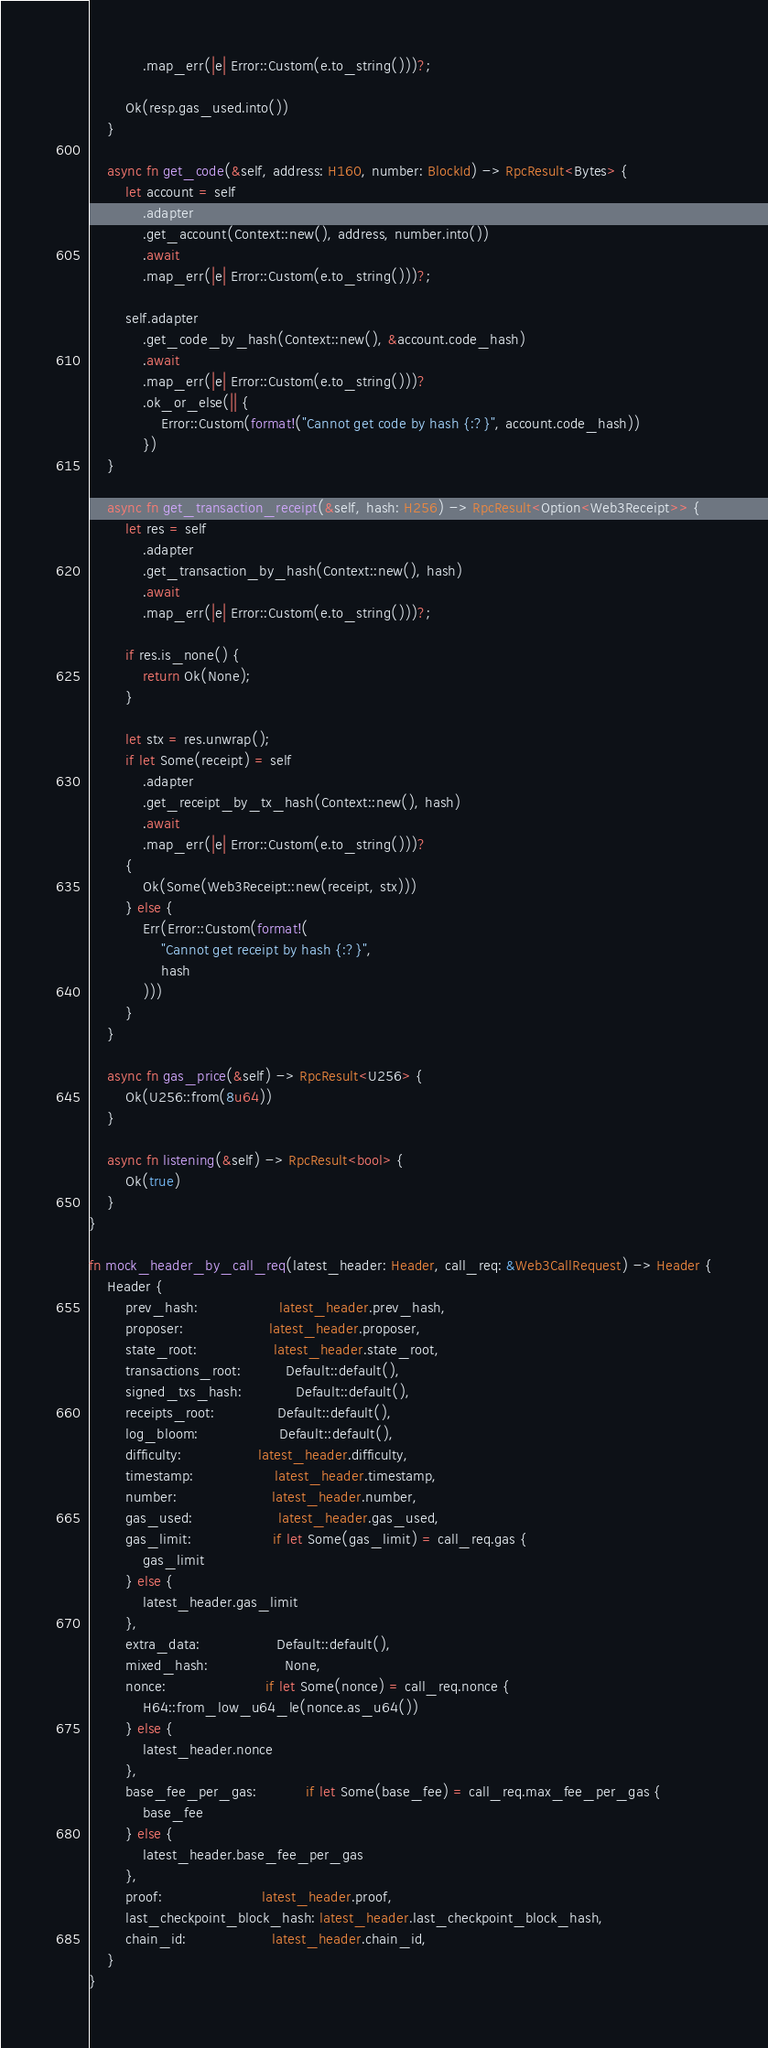Convert code to text. <code><loc_0><loc_0><loc_500><loc_500><_Rust_>            .map_err(|e| Error::Custom(e.to_string()))?;

        Ok(resp.gas_used.into())
    }

    async fn get_code(&self, address: H160, number: BlockId) -> RpcResult<Bytes> {
        let account = self
            .adapter
            .get_account(Context::new(), address, number.into())
            .await
            .map_err(|e| Error::Custom(e.to_string()))?;

        self.adapter
            .get_code_by_hash(Context::new(), &account.code_hash)
            .await
            .map_err(|e| Error::Custom(e.to_string()))?
            .ok_or_else(|| {
                Error::Custom(format!("Cannot get code by hash {:?}", account.code_hash))
            })
    }

    async fn get_transaction_receipt(&self, hash: H256) -> RpcResult<Option<Web3Receipt>> {
        let res = self
            .adapter
            .get_transaction_by_hash(Context::new(), hash)
            .await
            .map_err(|e| Error::Custom(e.to_string()))?;

        if res.is_none() {
            return Ok(None);
        }

        let stx = res.unwrap();
        if let Some(receipt) = self
            .adapter
            .get_receipt_by_tx_hash(Context::new(), hash)
            .await
            .map_err(|e| Error::Custom(e.to_string()))?
        {
            Ok(Some(Web3Receipt::new(receipt, stx)))
        } else {
            Err(Error::Custom(format!(
                "Cannot get receipt by hash {:?}",
                hash
            )))
        }
    }

    async fn gas_price(&self) -> RpcResult<U256> {
        Ok(U256::from(8u64))
    }

    async fn listening(&self) -> RpcResult<bool> {
        Ok(true)
    }
}

fn mock_header_by_call_req(latest_header: Header, call_req: &Web3CallRequest) -> Header {
    Header {
        prev_hash:                  latest_header.prev_hash,
        proposer:                   latest_header.proposer,
        state_root:                 latest_header.state_root,
        transactions_root:          Default::default(),
        signed_txs_hash:            Default::default(),
        receipts_root:              Default::default(),
        log_bloom:                  Default::default(),
        difficulty:                 latest_header.difficulty,
        timestamp:                  latest_header.timestamp,
        number:                     latest_header.number,
        gas_used:                   latest_header.gas_used,
        gas_limit:                  if let Some(gas_limit) = call_req.gas {
            gas_limit
        } else {
            latest_header.gas_limit
        },
        extra_data:                 Default::default(),
        mixed_hash:                 None,
        nonce:                      if let Some(nonce) = call_req.nonce {
            H64::from_low_u64_le(nonce.as_u64())
        } else {
            latest_header.nonce
        },
        base_fee_per_gas:           if let Some(base_fee) = call_req.max_fee_per_gas {
            base_fee
        } else {
            latest_header.base_fee_per_gas
        },
        proof:                      latest_header.proof,
        last_checkpoint_block_hash: latest_header.last_checkpoint_block_hash,
        chain_id:                   latest_header.chain_id,
    }
}
</code> 